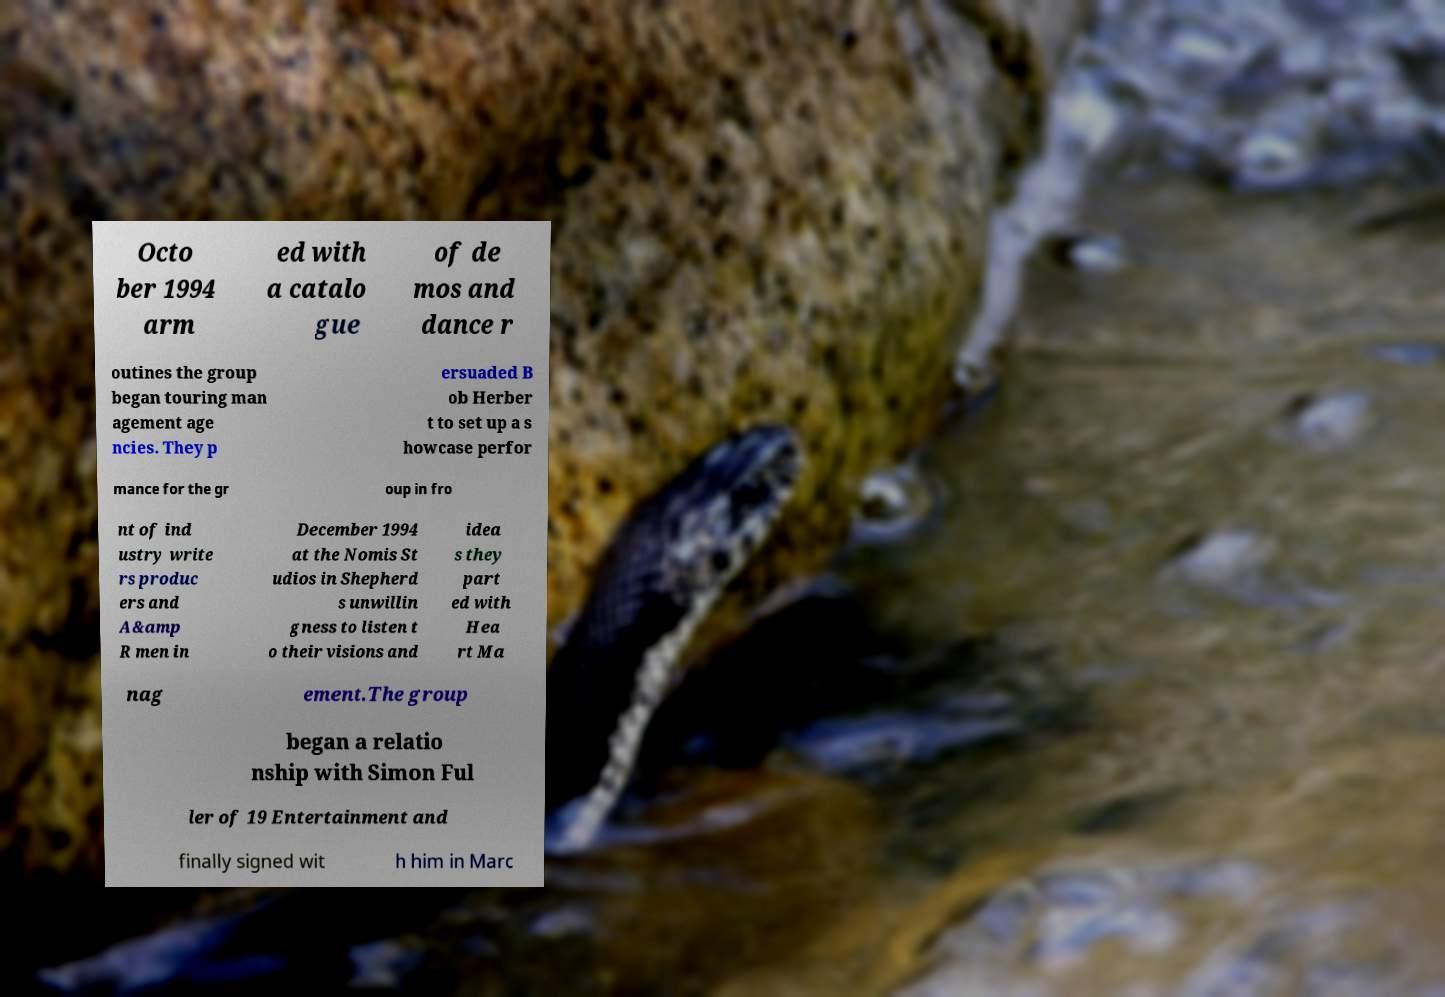I need the written content from this picture converted into text. Can you do that? Octo ber 1994 arm ed with a catalo gue of de mos and dance r outines the group began touring man agement age ncies. They p ersuaded B ob Herber t to set up a s howcase perfor mance for the gr oup in fro nt of ind ustry write rs produc ers and A&amp R men in December 1994 at the Nomis St udios in Shepherd s unwillin gness to listen t o their visions and idea s they part ed with Hea rt Ma nag ement.The group began a relatio nship with Simon Ful ler of 19 Entertainment and finally signed wit h him in Marc 